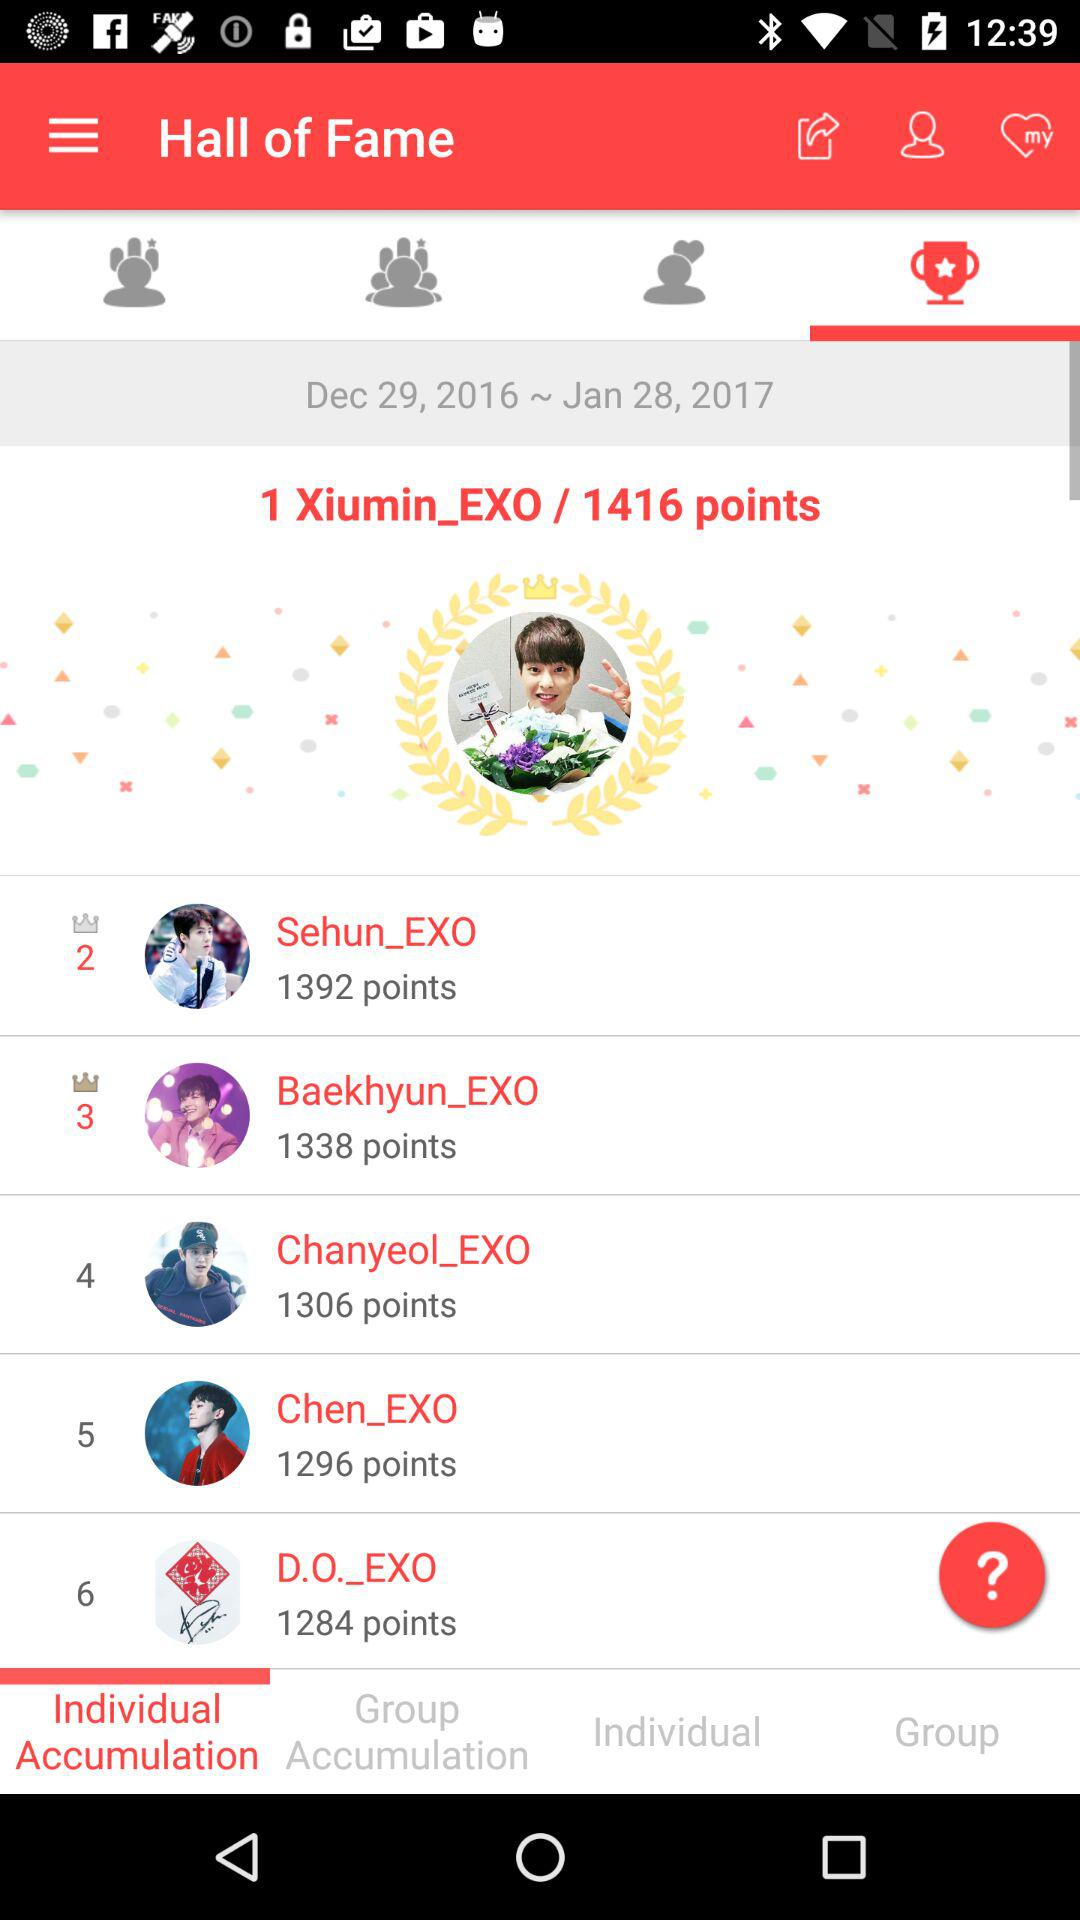Who are the top three rankers? The top three rankers are "Xiumin_EXO", "Sehun_EXO" and "Baekhyun_EXO". 